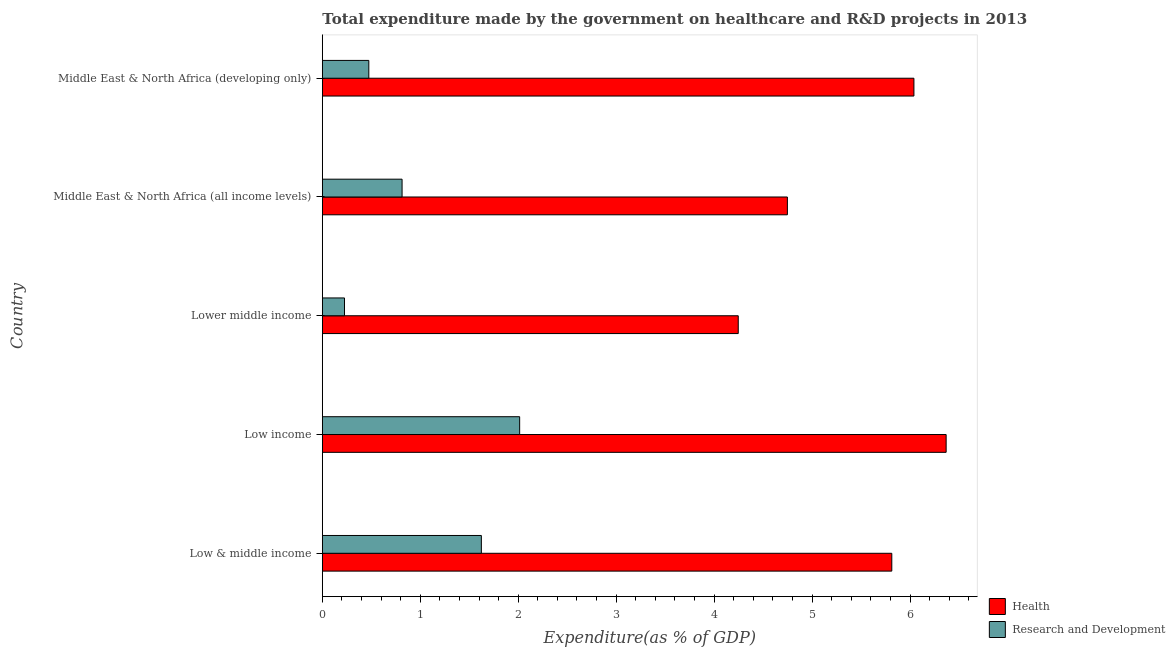How many different coloured bars are there?
Provide a short and direct response. 2. How many groups of bars are there?
Keep it short and to the point. 5. Are the number of bars on each tick of the Y-axis equal?
Keep it short and to the point. Yes. How many bars are there on the 3rd tick from the top?
Your answer should be very brief. 2. What is the label of the 2nd group of bars from the top?
Give a very brief answer. Middle East & North Africa (all income levels). In how many cases, is the number of bars for a given country not equal to the number of legend labels?
Your response must be concise. 0. What is the expenditure in healthcare in Lower middle income?
Offer a terse response. 4.25. Across all countries, what is the maximum expenditure in healthcare?
Give a very brief answer. 6.37. Across all countries, what is the minimum expenditure in healthcare?
Provide a succinct answer. 4.25. In which country was the expenditure in r&d maximum?
Make the answer very short. Low income. In which country was the expenditure in healthcare minimum?
Your answer should be very brief. Lower middle income. What is the total expenditure in healthcare in the graph?
Provide a short and direct response. 27.22. What is the difference between the expenditure in healthcare in Low & middle income and that in Low income?
Your response must be concise. -0.56. What is the difference between the expenditure in healthcare in Lower middle income and the expenditure in r&d in Middle East & North Africa (all income levels)?
Give a very brief answer. 3.43. What is the average expenditure in healthcare per country?
Offer a terse response. 5.44. What is the difference between the expenditure in healthcare and expenditure in r&d in Low & middle income?
Your response must be concise. 4.19. What is the difference between the highest and the second highest expenditure in healthcare?
Give a very brief answer. 0.33. What is the difference between the highest and the lowest expenditure in r&d?
Offer a terse response. 1.79. In how many countries, is the expenditure in healthcare greater than the average expenditure in healthcare taken over all countries?
Keep it short and to the point. 3. Is the sum of the expenditure in healthcare in Low income and Middle East & North Africa (all income levels) greater than the maximum expenditure in r&d across all countries?
Offer a very short reply. Yes. What does the 1st bar from the top in Middle East & North Africa (all income levels) represents?
Give a very brief answer. Research and Development. What does the 1st bar from the bottom in Low & middle income represents?
Keep it short and to the point. Health. Are the values on the major ticks of X-axis written in scientific E-notation?
Your response must be concise. No. Where does the legend appear in the graph?
Keep it short and to the point. Bottom right. How many legend labels are there?
Your answer should be very brief. 2. What is the title of the graph?
Give a very brief answer. Total expenditure made by the government on healthcare and R&D projects in 2013. Does "% of GNI" appear as one of the legend labels in the graph?
Your response must be concise. No. What is the label or title of the X-axis?
Ensure brevity in your answer.  Expenditure(as % of GDP). What is the Expenditure(as % of GDP) in Health in Low & middle income?
Offer a terse response. 5.81. What is the Expenditure(as % of GDP) in Research and Development in Low & middle income?
Your response must be concise. 1.62. What is the Expenditure(as % of GDP) of Health in Low income?
Your response must be concise. 6.37. What is the Expenditure(as % of GDP) in Research and Development in Low income?
Give a very brief answer. 2.01. What is the Expenditure(as % of GDP) in Health in Lower middle income?
Offer a very short reply. 4.25. What is the Expenditure(as % of GDP) in Research and Development in Lower middle income?
Your response must be concise. 0.23. What is the Expenditure(as % of GDP) of Health in Middle East & North Africa (all income levels)?
Offer a terse response. 4.75. What is the Expenditure(as % of GDP) in Research and Development in Middle East & North Africa (all income levels)?
Your answer should be very brief. 0.81. What is the Expenditure(as % of GDP) in Health in Middle East & North Africa (developing only)?
Provide a succinct answer. 6.04. What is the Expenditure(as % of GDP) of Research and Development in Middle East & North Africa (developing only)?
Offer a terse response. 0.47. Across all countries, what is the maximum Expenditure(as % of GDP) in Health?
Provide a short and direct response. 6.37. Across all countries, what is the maximum Expenditure(as % of GDP) in Research and Development?
Keep it short and to the point. 2.01. Across all countries, what is the minimum Expenditure(as % of GDP) of Health?
Ensure brevity in your answer.  4.25. Across all countries, what is the minimum Expenditure(as % of GDP) of Research and Development?
Ensure brevity in your answer.  0.23. What is the total Expenditure(as % of GDP) of Health in the graph?
Give a very brief answer. 27.22. What is the total Expenditure(as % of GDP) of Research and Development in the graph?
Your answer should be very brief. 5.15. What is the difference between the Expenditure(as % of GDP) in Health in Low & middle income and that in Low income?
Provide a succinct answer. -0.55. What is the difference between the Expenditure(as % of GDP) of Research and Development in Low & middle income and that in Low income?
Your answer should be very brief. -0.39. What is the difference between the Expenditure(as % of GDP) of Health in Low & middle income and that in Lower middle income?
Give a very brief answer. 1.57. What is the difference between the Expenditure(as % of GDP) in Research and Development in Low & middle income and that in Lower middle income?
Offer a very short reply. 1.4. What is the difference between the Expenditure(as % of GDP) in Health in Low & middle income and that in Middle East & North Africa (all income levels)?
Provide a succinct answer. 1.07. What is the difference between the Expenditure(as % of GDP) in Research and Development in Low & middle income and that in Middle East & North Africa (all income levels)?
Offer a terse response. 0.81. What is the difference between the Expenditure(as % of GDP) in Health in Low & middle income and that in Middle East & North Africa (developing only)?
Your answer should be compact. -0.23. What is the difference between the Expenditure(as % of GDP) in Research and Development in Low & middle income and that in Middle East & North Africa (developing only)?
Give a very brief answer. 1.15. What is the difference between the Expenditure(as % of GDP) of Health in Low income and that in Lower middle income?
Offer a terse response. 2.12. What is the difference between the Expenditure(as % of GDP) in Research and Development in Low income and that in Lower middle income?
Make the answer very short. 1.79. What is the difference between the Expenditure(as % of GDP) of Health in Low income and that in Middle East & North Africa (all income levels)?
Offer a terse response. 1.62. What is the difference between the Expenditure(as % of GDP) of Research and Development in Low income and that in Middle East & North Africa (all income levels)?
Offer a very short reply. 1.2. What is the difference between the Expenditure(as % of GDP) in Health in Low income and that in Middle East & North Africa (developing only)?
Your answer should be very brief. 0.33. What is the difference between the Expenditure(as % of GDP) of Research and Development in Low income and that in Middle East & North Africa (developing only)?
Provide a short and direct response. 1.54. What is the difference between the Expenditure(as % of GDP) in Health in Lower middle income and that in Middle East & North Africa (all income levels)?
Ensure brevity in your answer.  -0.5. What is the difference between the Expenditure(as % of GDP) in Research and Development in Lower middle income and that in Middle East & North Africa (all income levels)?
Your answer should be very brief. -0.59. What is the difference between the Expenditure(as % of GDP) in Health in Lower middle income and that in Middle East & North Africa (developing only)?
Make the answer very short. -1.79. What is the difference between the Expenditure(as % of GDP) of Research and Development in Lower middle income and that in Middle East & North Africa (developing only)?
Ensure brevity in your answer.  -0.25. What is the difference between the Expenditure(as % of GDP) in Health in Middle East & North Africa (all income levels) and that in Middle East & North Africa (developing only)?
Your response must be concise. -1.29. What is the difference between the Expenditure(as % of GDP) of Research and Development in Middle East & North Africa (all income levels) and that in Middle East & North Africa (developing only)?
Your answer should be compact. 0.34. What is the difference between the Expenditure(as % of GDP) of Health in Low & middle income and the Expenditure(as % of GDP) of Research and Development in Low income?
Your answer should be compact. 3.8. What is the difference between the Expenditure(as % of GDP) of Health in Low & middle income and the Expenditure(as % of GDP) of Research and Development in Lower middle income?
Offer a very short reply. 5.59. What is the difference between the Expenditure(as % of GDP) of Health in Low & middle income and the Expenditure(as % of GDP) of Research and Development in Middle East & North Africa (developing only)?
Your answer should be very brief. 5.34. What is the difference between the Expenditure(as % of GDP) in Health in Low income and the Expenditure(as % of GDP) in Research and Development in Lower middle income?
Your answer should be very brief. 6.14. What is the difference between the Expenditure(as % of GDP) in Health in Low income and the Expenditure(as % of GDP) in Research and Development in Middle East & North Africa (all income levels)?
Offer a terse response. 5.55. What is the difference between the Expenditure(as % of GDP) in Health in Low income and the Expenditure(as % of GDP) in Research and Development in Middle East & North Africa (developing only)?
Your answer should be very brief. 5.89. What is the difference between the Expenditure(as % of GDP) in Health in Lower middle income and the Expenditure(as % of GDP) in Research and Development in Middle East & North Africa (all income levels)?
Ensure brevity in your answer.  3.43. What is the difference between the Expenditure(as % of GDP) in Health in Lower middle income and the Expenditure(as % of GDP) in Research and Development in Middle East & North Africa (developing only)?
Your answer should be compact. 3.77. What is the difference between the Expenditure(as % of GDP) in Health in Middle East & North Africa (all income levels) and the Expenditure(as % of GDP) in Research and Development in Middle East & North Africa (developing only)?
Provide a short and direct response. 4.27. What is the average Expenditure(as % of GDP) of Health per country?
Your answer should be very brief. 5.44. What is the average Expenditure(as % of GDP) in Research and Development per country?
Your answer should be very brief. 1.03. What is the difference between the Expenditure(as % of GDP) of Health and Expenditure(as % of GDP) of Research and Development in Low & middle income?
Offer a very short reply. 4.19. What is the difference between the Expenditure(as % of GDP) of Health and Expenditure(as % of GDP) of Research and Development in Low income?
Your answer should be very brief. 4.35. What is the difference between the Expenditure(as % of GDP) of Health and Expenditure(as % of GDP) of Research and Development in Lower middle income?
Offer a terse response. 4.02. What is the difference between the Expenditure(as % of GDP) in Health and Expenditure(as % of GDP) in Research and Development in Middle East & North Africa (all income levels)?
Your answer should be compact. 3.93. What is the difference between the Expenditure(as % of GDP) in Health and Expenditure(as % of GDP) in Research and Development in Middle East & North Africa (developing only)?
Ensure brevity in your answer.  5.57. What is the ratio of the Expenditure(as % of GDP) of Health in Low & middle income to that in Low income?
Offer a terse response. 0.91. What is the ratio of the Expenditure(as % of GDP) in Research and Development in Low & middle income to that in Low income?
Provide a short and direct response. 0.81. What is the ratio of the Expenditure(as % of GDP) in Health in Low & middle income to that in Lower middle income?
Offer a very short reply. 1.37. What is the ratio of the Expenditure(as % of GDP) of Research and Development in Low & middle income to that in Lower middle income?
Your response must be concise. 7.17. What is the ratio of the Expenditure(as % of GDP) in Health in Low & middle income to that in Middle East & North Africa (all income levels)?
Make the answer very short. 1.22. What is the ratio of the Expenditure(as % of GDP) in Research and Development in Low & middle income to that in Middle East & North Africa (all income levels)?
Offer a very short reply. 1.99. What is the ratio of the Expenditure(as % of GDP) of Health in Low & middle income to that in Middle East & North Africa (developing only)?
Make the answer very short. 0.96. What is the ratio of the Expenditure(as % of GDP) of Research and Development in Low & middle income to that in Middle East & North Africa (developing only)?
Offer a terse response. 3.42. What is the ratio of the Expenditure(as % of GDP) in Health in Low income to that in Lower middle income?
Keep it short and to the point. 1.5. What is the ratio of the Expenditure(as % of GDP) of Research and Development in Low income to that in Lower middle income?
Your response must be concise. 8.9. What is the ratio of the Expenditure(as % of GDP) in Health in Low income to that in Middle East & North Africa (all income levels)?
Provide a short and direct response. 1.34. What is the ratio of the Expenditure(as % of GDP) of Research and Development in Low income to that in Middle East & North Africa (all income levels)?
Ensure brevity in your answer.  2.47. What is the ratio of the Expenditure(as % of GDP) of Health in Low income to that in Middle East & North Africa (developing only)?
Provide a short and direct response. 1.05. What is the ratio of the Expenditure(as % of GDP) in Research and Development in Low income to that in Middle East & North Africa (developing only)?
Your answer should be very brief. 4.24. What is the ratio of the Expenditure(as % of GDP) in Health in Lower middle income to that in Middle East & North Africa (all income levels)?
Ensure brevity in your answer.  0.89. What is the ratio of the Expenditure(as % of GDP) in Research and Development in Lower middle income to that in Middle East & North Africa (all income levels)?
Offer a terse response. 0.28. What is the ratio of the Expenditure(as % of GDP) of Health in Lower middle income to that in Middle East & North Africa (developing only)?
Your response must be concise. 0.7. What is the ratio of the Expenditure(as % of GDP) in Research and Development in Lower middle income to that in Middle East & North Africa (developing only)?
Offer a very short reply. 0.48. What is the ratio of the Expenditure(as % of GDP) in Health in Middle East & North Africa (all income levels) to that in Middle East & North Africa (developing only)?
Your response must be concise. 0.79. What is the ratio of the Expenditure(as % of GDP) in Research and Development in Middle East & North Africa (all income levels) to that in Middle East & North Africa (developing only)?
Make the answer very short. 1.72. What is the difference between the highest and the second highest Expenditure(as % of GDP) in Health?
Ensure brevity in your answer.  0.33. What is the difference between the highest and the second highest Expenditure(as % of GDP) of Research and Development?
Provide a short and direct response. 0.39. What is the difference between the highest and the lowest Expenditure(as % of GDP) in Health?
Ensure brevity in your answer.  2.12. What is the difference between the highest and the lowest Expenditure(as % of GDP) in Research and Development?
Offer a very short reply. 1.79. 